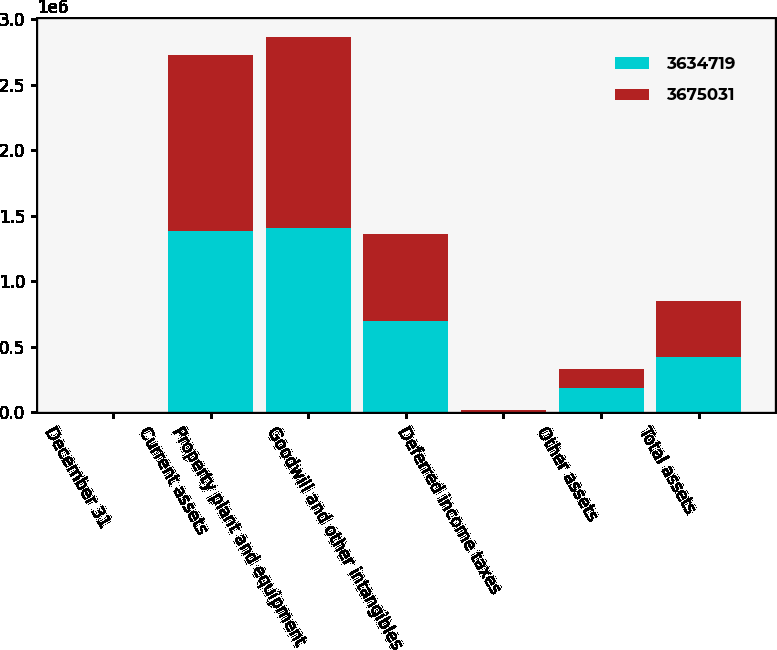<chart> <loc_0><loc_0><loc_500><loc_500><stacked_bar_chart><ecel><fcel>December 31<fcel>Current assets<fcel>Property plant and equipment<fcel>Goodwill and other intangibles<fcel>Deferred income taxes<fcel>Other assets<fcel>Total assets<nl><fcel>3.63472e+06<fcel>2009<fcel>1.38543e+06<fcel>1.40477e+06<fcel>697100<fcel>4353<fcel>183377<fcel>424413<nl><fcel>3.67503e+06<fcel>2008<fcel>1.34494e+06<fcel>1.45895e+06<fcel>665449<fcel>13815<fcel>151561<fcel>424413<nl></chart> 